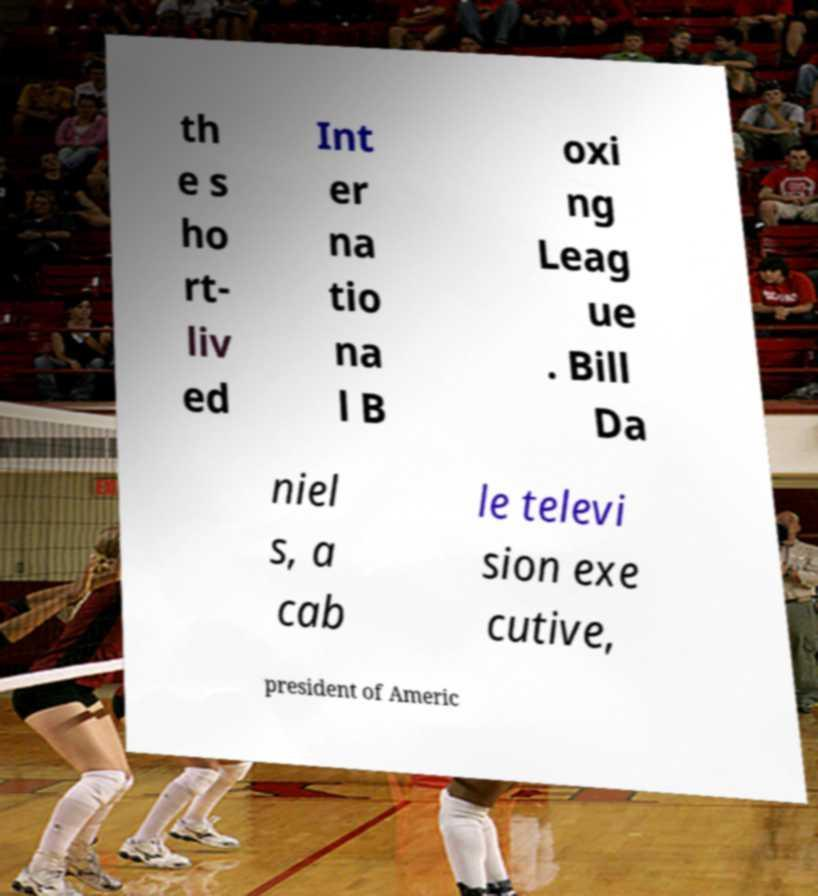I need the written content from this picture converted into text. Can you do that? th e s ho rt- liv ed Int er na tio na l B oxi ng Leag ue . Bill Da niel s, a cab le televi sion exe cutive, president of Americ 